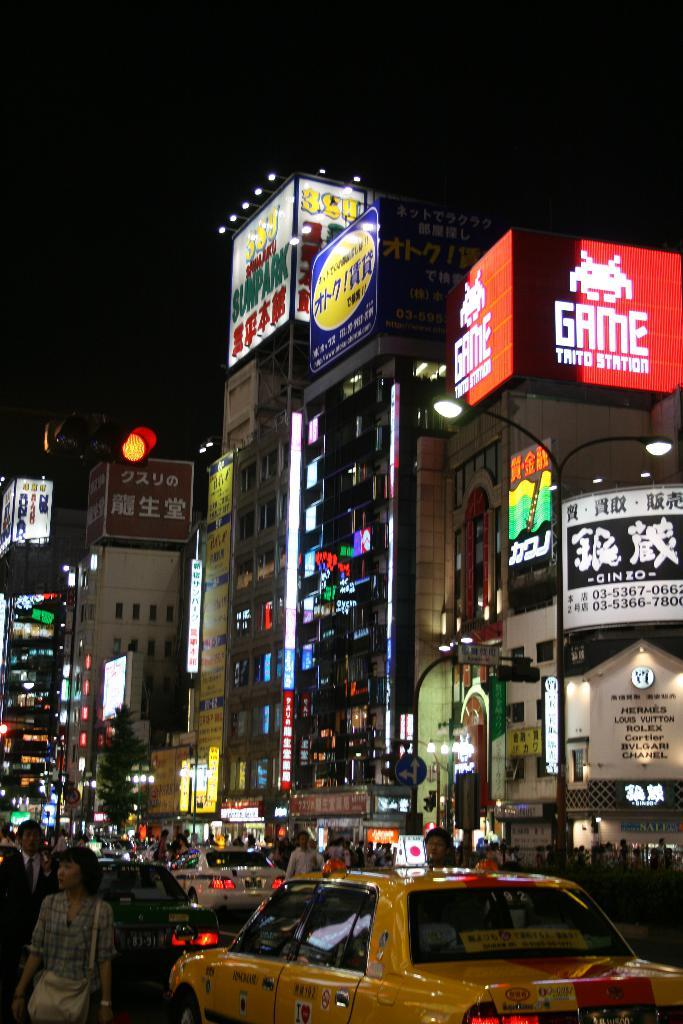<image>
Write a terse but informative summary of the picture. A busy city square at night shows people walking and congested traffic in a Japanese city filled with ads for products like Game Trito Station. 